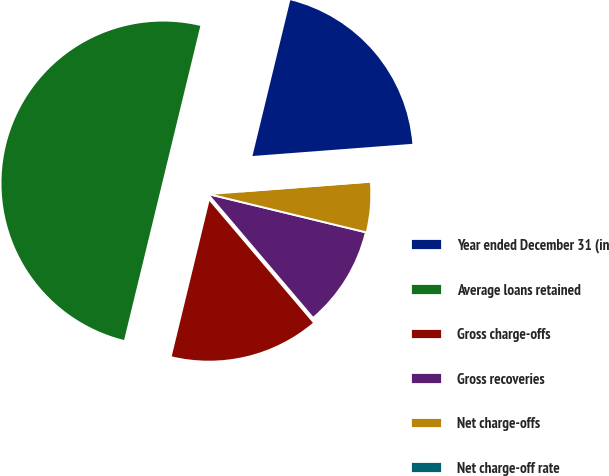Convert chart. <chart><loc_0><loc_0><loc_500><loc_500><pie_chart><fcel>Year ended December 31 (in<fcel>Average loans retained<fcel>Gross charge-offs<fcel>Gross recoveries<fcel>Net charge-offs<fcel>Net charge-off rate<nl><fcel>20.0%<fcel>50.0%<fcel>15.0%<fcel>10.0%<fcel>5.0%<fcel>0.0%<nl></chart> 